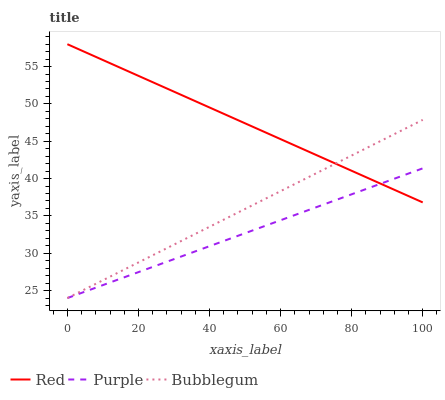Does Purple have the minimum area under the curve?
Answer yes or no. Yes. Does Red have the maximum area under the curve?
Answer yes or no. Yes. Does Bubblegum have the minimum area under the curve?
Answer yes or no. No. Does Bubblegum have the maximum area under the curve?
Answer yes or no. No. Is Bubblegum the smoothest?
Answer yes or no. Yes. Is Red the roughest?
Answer yes or no. Yes. Is Red the smoothest?
Answer yes or no. No. Is Bubblegum the roughest?
Answer yes or no. No. Does Purple have the lowest value?
Answer yes or no. Yes. Does Red have the lowest value?
Answer yes or no. No. Does Red have the highest value?
Answer yes or no. Yes. Does Bubblegum have the highest value?
Answer yes or no. No. Does Bubblegum intersect Purple?
Answer yes or no. Yes. Is Bubblegum less than Purple?
Answer yes or no. No. Is Bubblegum greater than Purple?
Answer yes or no. No. 